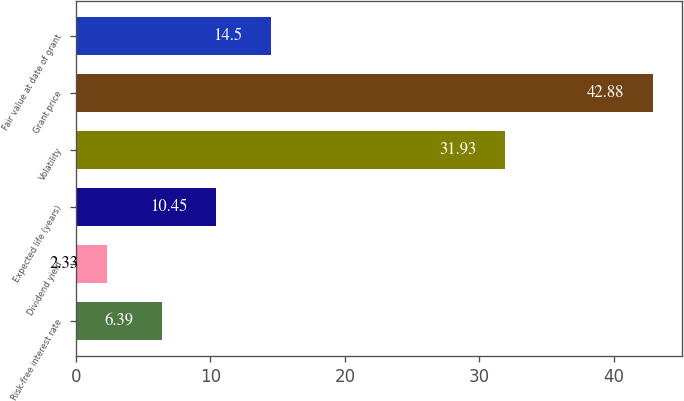<chart> <loc_0><loc_0><loc_500><loc_500><bar_chart><fcel>Risk-free interest rate<fcel>Dividend yield<fcel>Expected life (years)<fcel>Volatility<fcel>Grant price<fcel>Fair value at date of grant<nl><fcel>6.39<fcel>2.33<fcel>10.45<fcel>31.93<fcel>42.88<fcel>14.5<nl></chart> 